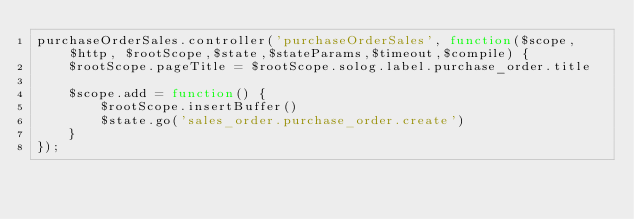Convert code to text. <code><loc_0><loc_0><loc_500><loc_500><_JavaScript_>purchaseOrderSales.controller('purchaseOrderSales', function($scope, $http, $rootScope,$state,$stateParams,$timeout,$compile) {
    $rootScope.pageTitle = $rootScope.solog.label.purchase_order.title

    $scope.add = function() {
        $rootScope.insertBuffer()
        $state.go('sales_order.purchase_order.create')
    }
});</code> 